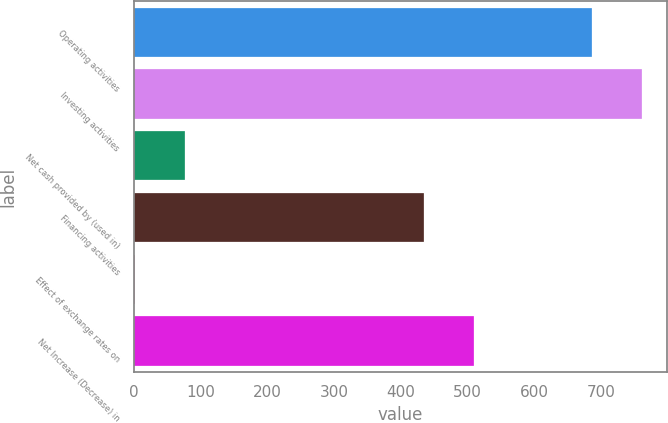Convert chart to OTSL. <chart><loc_0><loc_0><loc_500><loc_500><bar_chart><fcel>Operating activities<fcel>Investing activities<fcel>Net cash provided by (used in)<fcel>Financing activities<fcel>Effect of exchange rates on<fcel>Net Increase (Decrease) in<nl><fcel>686<fcel>760.8<fcel>75.8<fcel>434<fcel>1<fcel>508.8<nl></chart> 